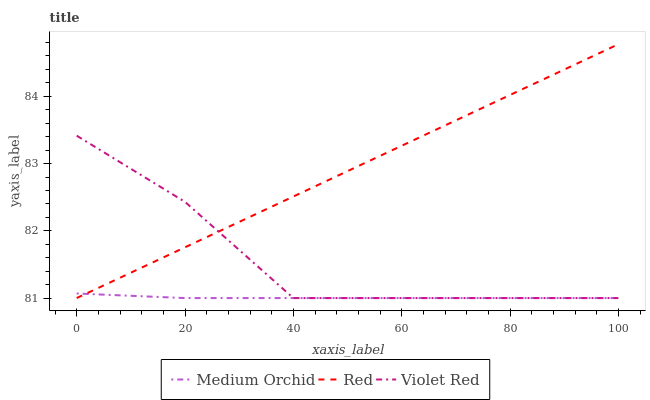Does Medium Orchid have the minimum area under the curve?
Answer yes or no. Yes. Does Red have the maximum area under the curve?
Answer yes or no. Yes. Does Red have the minimum area under the curve?
Answer yes or no. No. Does Medium Orchid have the maximum area under the curve?
Answer yes or no. No. Is Red the smoothest?
Answer yes or no. Yes. Is Violet Red the roughest?
Answer yes or no. Yes. Is Medium Orchid the smoothest?
Answer yes or no. No. Is Medium Orchid the roughest?
Answer yes or no. No. Does Violet Red have the lowest value?
Answer yes or no. Yes. Does Red have the highest value?
Answer yes or no. Yes. Does Medium Orchid have the highest value?
Answer yes or no. No. Does Medium Orchid intersect Violet Red?
Answer yes or no. Yes. Is Medium Orchid less than Violet Red?
Answer yes or no. No. Is Medium Orchid greater than Violet Red?
Answer yes or no. No. 